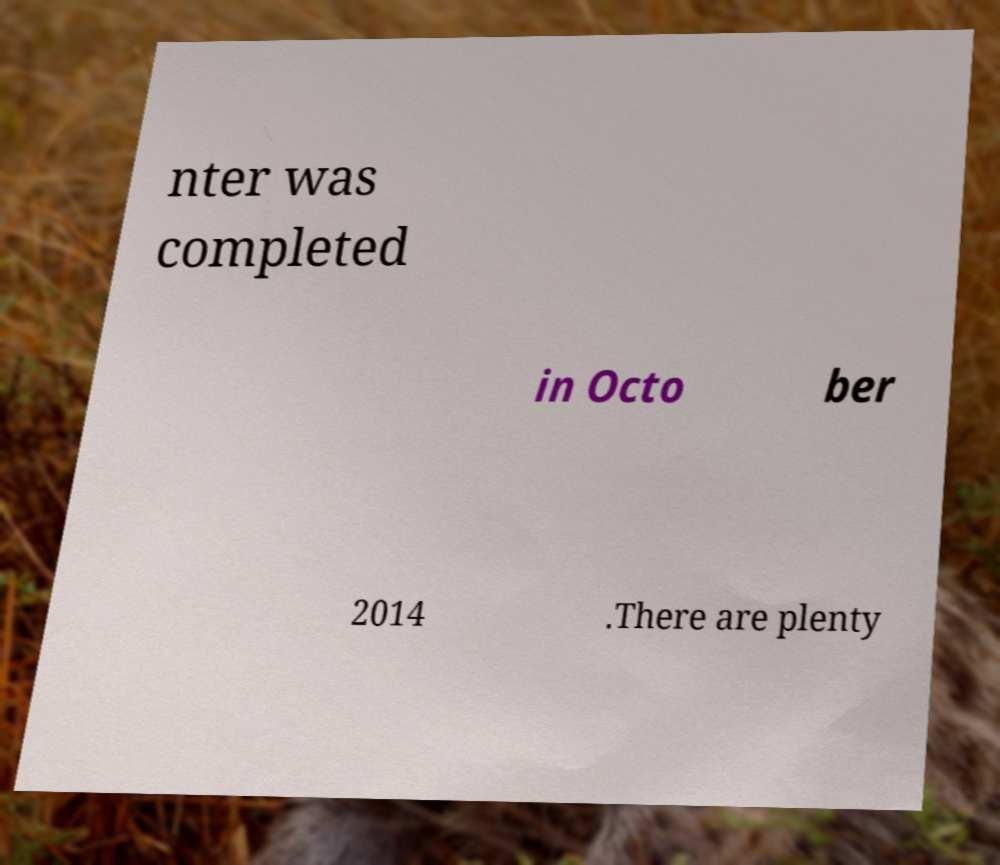There's text embedded in this image that I need extracted. Can you transcribe it verbatim? nter was completed in Octo ber 2014 .There are plenty 